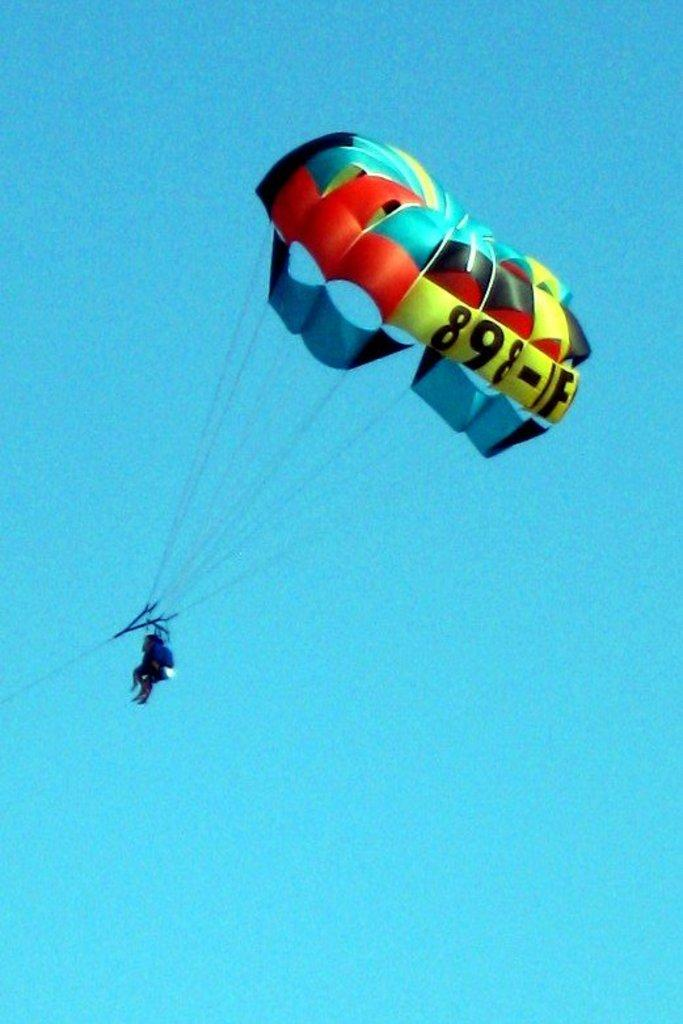What is happening to the person in the image? The person is flying in the air. How is the person flying in the air? The person is using a parachute. Can you describe the person's activity in the image? The person is flying in the air with the help of a parachute. What type of alarm is the person holding in the image? There is no alarm present in the image; the person is using a parachute to fly in the air. 